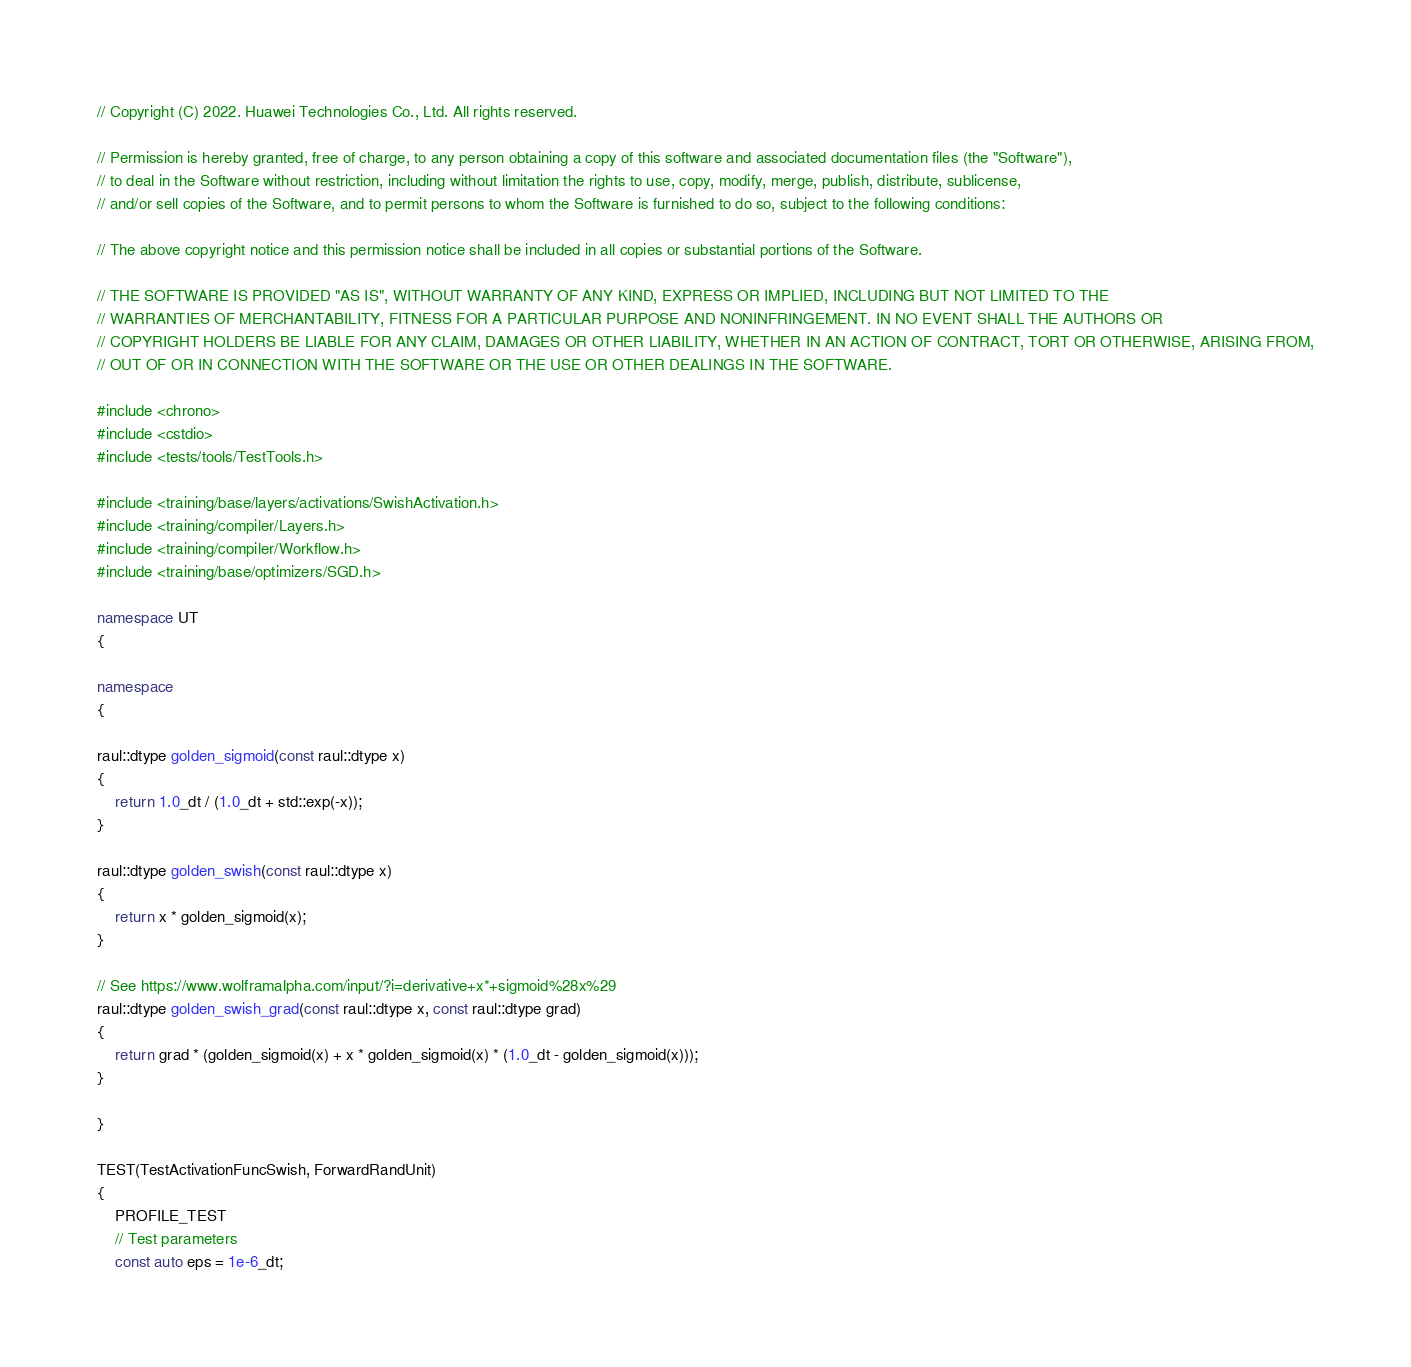<code> <loc_0><loc_0><loc_500><loc_500><_C++_>// Copyright (C) 2022. Huawei Technologies Co., Ltd. All rights reserved.

// Permission is hereby granted, free of charge, to any person obtaining a copy of this software and associated documentation files (the "Software"),
// to deal in the Software without restriction, including without limitation the rights to use, copy, modify, merge, publish, distribute, sublicense,
// and/or sell copies of the Software, and to permit persons to whom the Software is furnished to do so, subject to the following conditions:

// The above copyright notice and this permission notice shall be included in all copies or substantial portions of the Software.

// THE SOFTWARE IS PROVIDED "AS IS", WITHOUT WARRANTY OF ANY KIND, EXPRESS OR IMPLIED, INCLUDING BUT NOT LIMITED TO THE
// WARRANTIES OF MERCHANTABILITY, FITNESS FOR A PARTICULAR PURPOSE AND NONINFRINGEMENT. IN NO EVENT SHALL THE AUTHORS OR
// COPYRIGHT HOLDERS BE LIABLE FOR ANY CLAIM, DAMAGES OR OTHER LIABILITY, WHETHER IN AN ACTION OF CONTRACT, TORT OR OTHERWISE, ARISING FROM,
// OUT OF OR IN CONNECTION WITH THE SOFTWARE OR THE USE OR OTHER DEALINGS IN THE SOFTWARE.

#include <chrono>
#include <cstdio>
#include <tests/tools/TestTools.h>

#include <training/base/layers/activations/SwishActivation.h>
#include <training/compiler/Layers.h>
#include <training/compiler/Workflow.h>
#include <training/base/optimizers/SGD.h>

namespace UT
{

namespace
{

raul::dtype golden_sigmoid(const raul::dtype x)
{
    return 1.0_dt / (1.0_dt + std::exp(-x));
}

raul::dtype golden_swish(const raul::dtype x)
{
    return x * golden_sigmoid(x);
}

// See https://www.wolframalpha.com/input/?i=derivative+x*+sigmoid%28x%29
raul::dtype golden_swish_grad(const raul::dtype x, const raul::dtype grad)
{
    return grad * (golden_sigmoid(x) + x * golden_sigmoid(x) * (1.0_dt - golden_sigmoid(x)));
}

}

TEST(TestActivationFuncSwish, ForwardRandUnit)
{
    PROFILE_TEST
    // Test parameters
    const auto eps = 1e-6_dt;</code> 